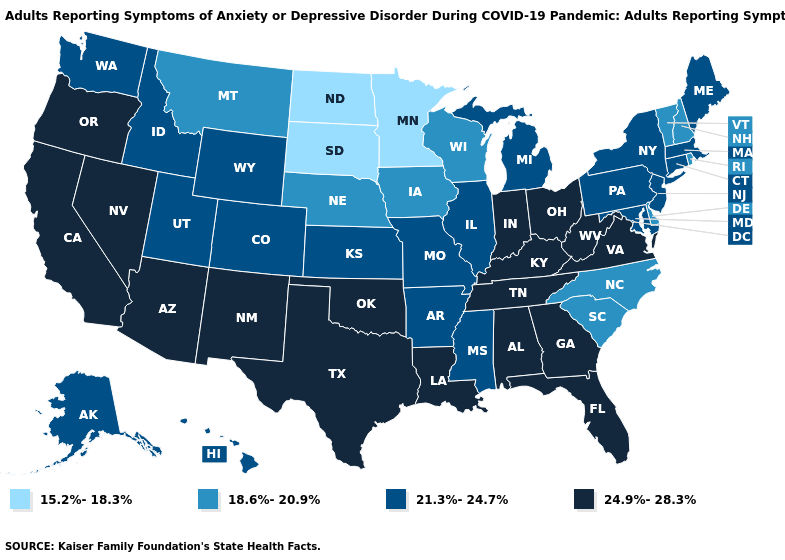Which states have the highest value in the USA?
Be succinct. Alabama, Arizona, California, Florida, Georgia, Indiana, Kentucky, Louisiana, Nevada, New Mexico, Ohio, Oklahoma, Oregon, Tennessee, Texas, Virginia, West Virginia. Does the first symbol in the legend represent the smallest category?
Answer briefly. Yes. Does Alabama have a higher value than Mississippi?
Quick response, please. Yes. Name the states that have a value in the range 18.6%-20.9%?
Keep it brief. Delaware, Iowa, Montana, Nebraska, New Hampshire, North Carolina, Rhode Island, South Carolina, Vermont, Wisconsin. Among the states that border Kentucky , does Missouri have the highest value?
Give a very brief answer. No. Does Ohio have the highest value in the MidWest?
Quick response, please. Yes. How many symbols are there in the legend?
Short answer required. 4. Which states hav the highest value in the Northeast?
Short answer required. Connecticut, Maine, Massachusetts, New Jersey, New York, Pennsylvania. Name the states that have a value in the range 24.9%-28.3%?
Give a very brief answer. Alabama, Arizona, California, Florida, Georgia, Indiana, Kentucky, Louisiana, Nevada, New Mexico, Ohio, Oklahoma, Oregon, Tennessee, Texas, Virginia, West Virginia. Which states have the lowest value in the West?
Be succinct. Montana. Does Florida have a lower value than Michigan?
Quick response, please. No. What is the lowest value in states that border Nebraska?
Keep it brief. 15.2%-18.3%. What is the value of South Carolina?
Write a very short answer. 18.6%-20.9%. What is the highest value in states that border Michigan?
Be succinct. 24.9%-28.3%. What is the value of Michigan?
Answer briefly. 21.3%-24.7%. 